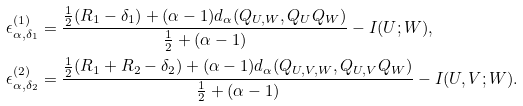<formula> <loc_0><loc_0><loc_500><loc_500>\epsilon ^ { ( 1 ) } _ { \alpha , \delta _ { 1 } } & = \frac { \frac { 1 } { 2 } ( R _ { 1 } - \delta _ { 1 } ) + ( \alpha - 1 ) d _ { \alpha } ( Q _ { U , W } , Q _ { U } Q _ { W } ) } { \frac { 1 } { 2 } + ( \alpha - 1 ) } - I ( U ; W ) , \\ \epsilon ^ { ( 2 ) } _ { \alpha , \delta _ { 2 } } & = \frac { \frac { 1 } { 2 } ( R _ { 1 } + R _ { 2 } - \delta _ { 2 } ) + ( \alpha - 1 ) d _ { \alpha } ( Q _ { U , V , W } , Q _ { U , V } Q _ { W } ) } { \frac { 1 } { 2 } + ( \alpha - 1 ) } - I ( U , V ; W ) .</formula> 